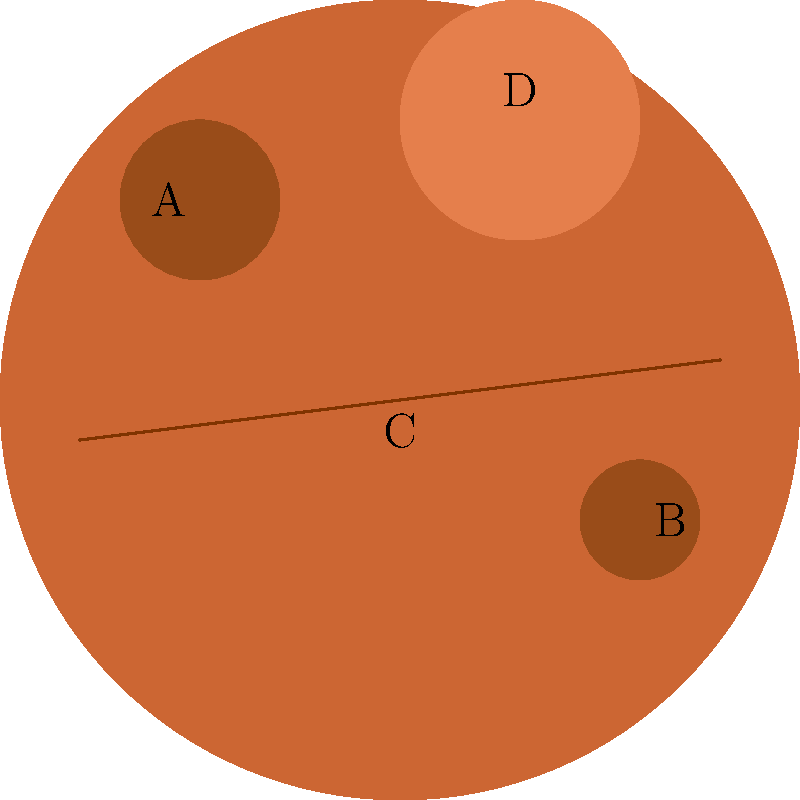In this satellite image of Mars, which feature labeled A, B, C, or D represents Olympus Mons, the largest known volcano in the Solar System? To identify Olympus Mons in this satellite image of Mars, let's analyze each labeled feature:

1. Feature A: This appears to be a small, circular depression, likely representing a crater on the Martian surface.

2. Feature B: Similar to A, this is another circular depression, probably another crater, but smaller than A.

3. Feature C: This long, dark line stretching across the image is likely the Valles Marineris, a vast canyon system on Mars.

4. Feature D: This large, circular elevation stands out from the surrounding terrain. It's significantly larger than the craters (A and B) and has a different color, indicating a different geological formation.

Olympus Mons is known for its enormous size and shield-like shape. It's the largest known volcano in the Solar System, standing about 21.9 km (13.6 mi) high and 600 km (370 mi) in diameter.

Given these characteristics, feature D best represents Olympus Mons. Its large size, circular shape, and elevated appearance match what we would expect to see in a satellite image of this massive volcanic structure.
Answer: D 